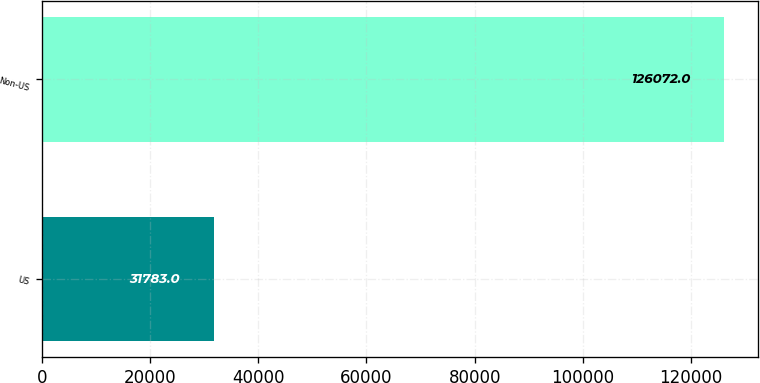Convert chart to OTSL. <chart><loc_0><loc_0><loc_500><loc_500><bar_chart><fcel>US<fcel>Non-US<nl><fcel>31783<fcel>126072<nl></chart> 